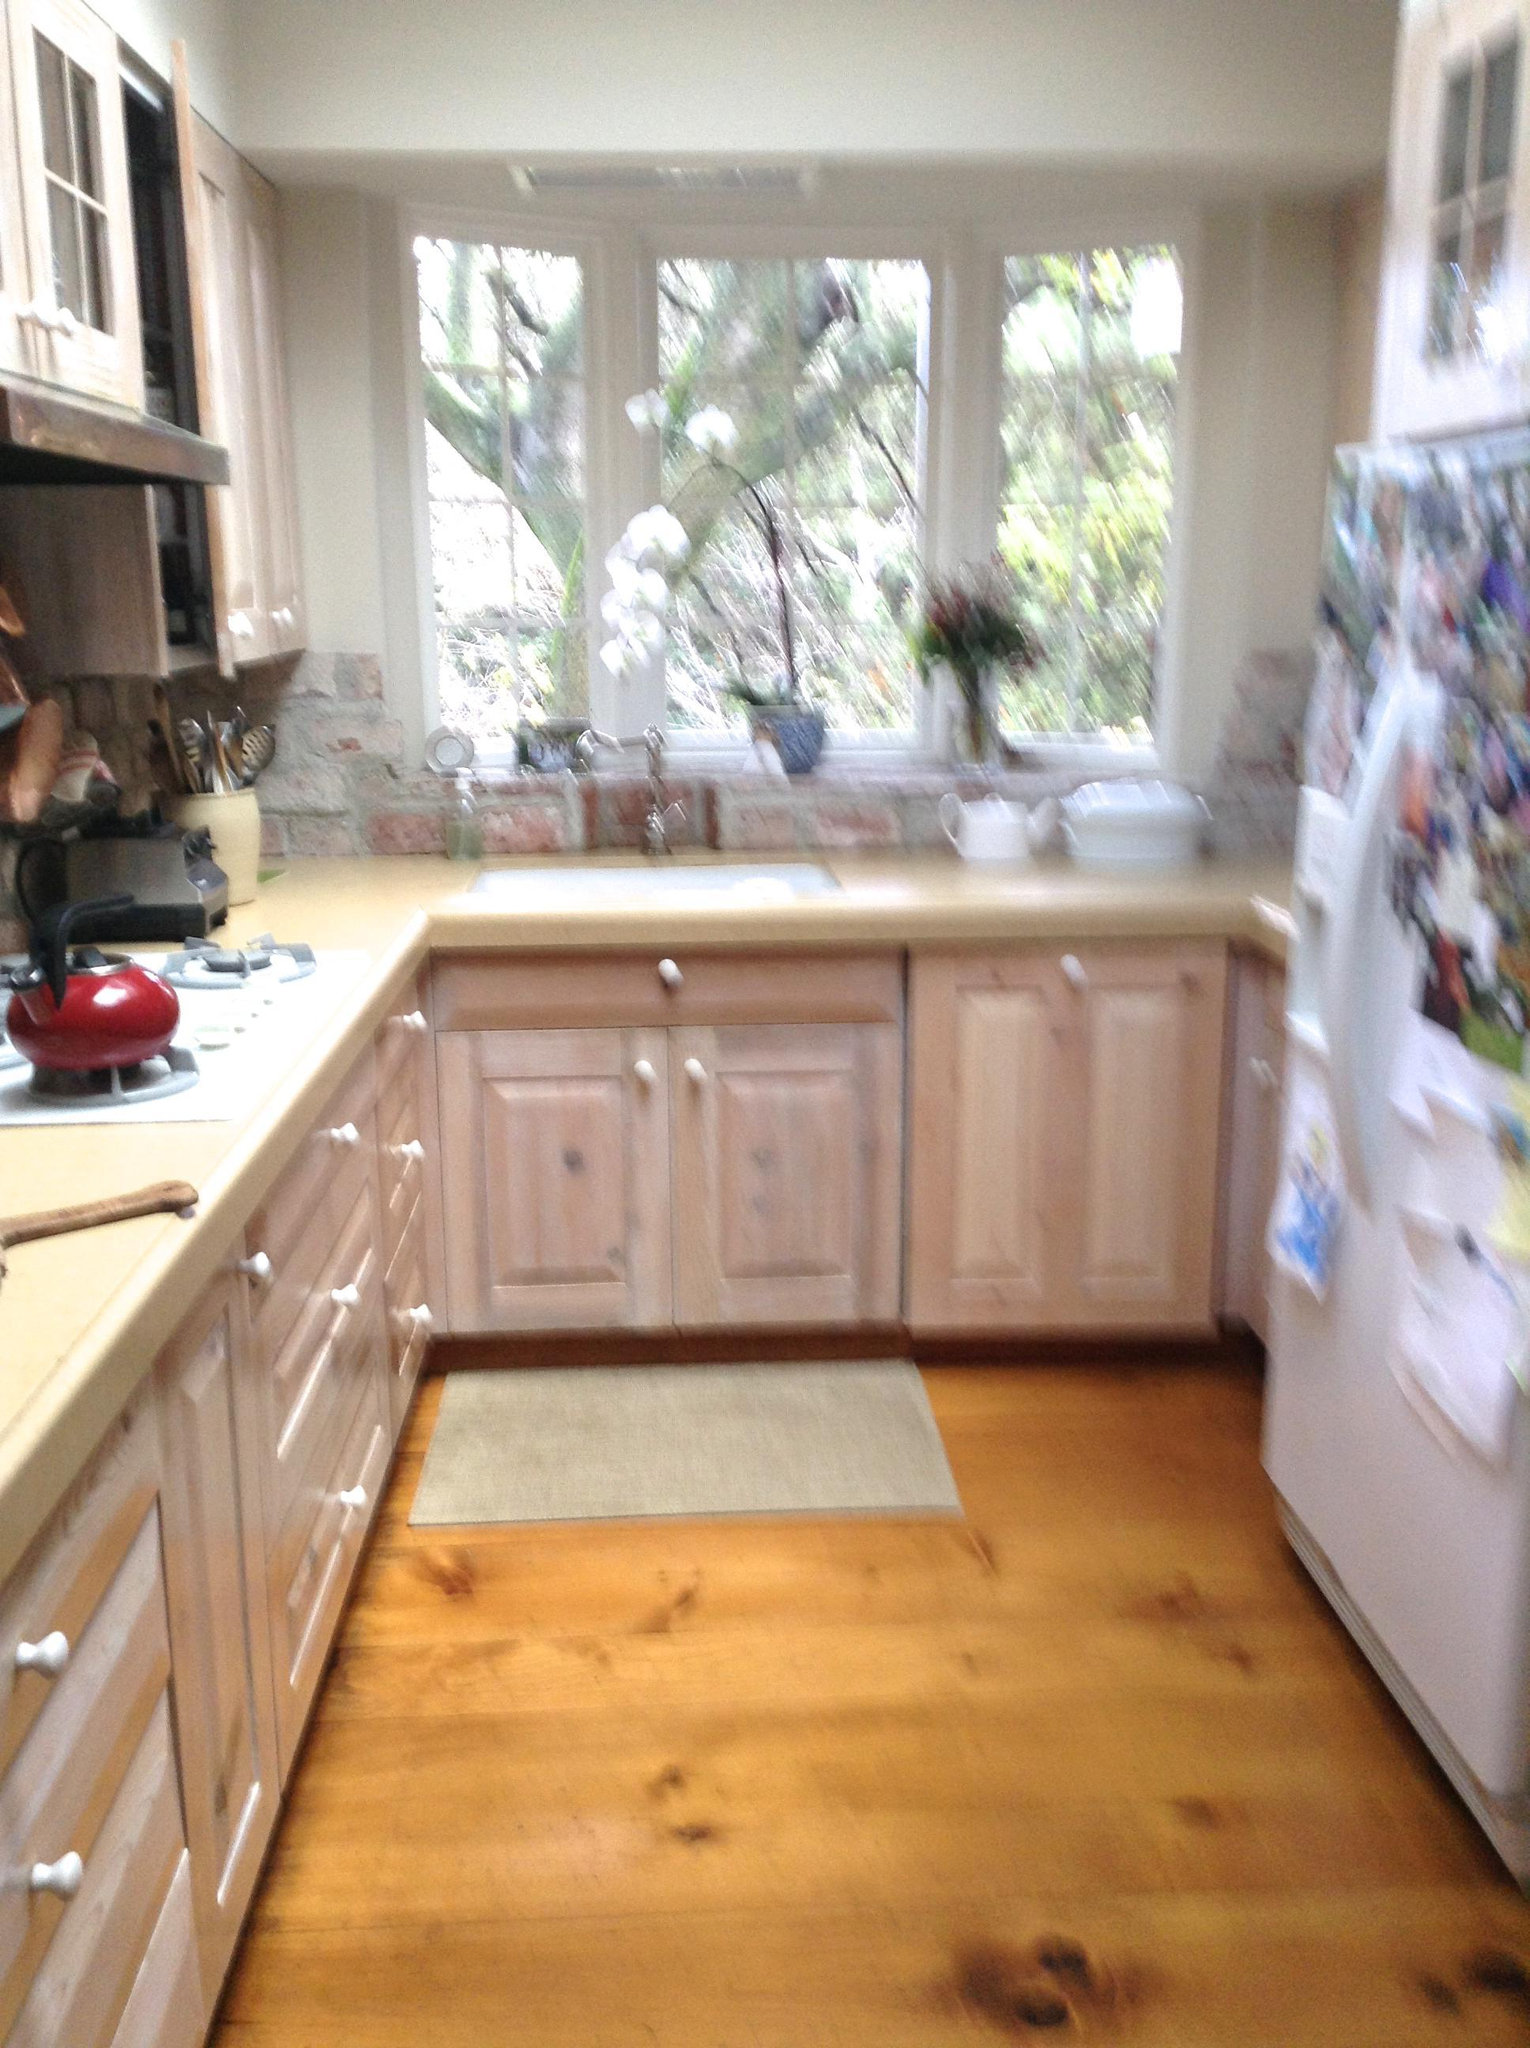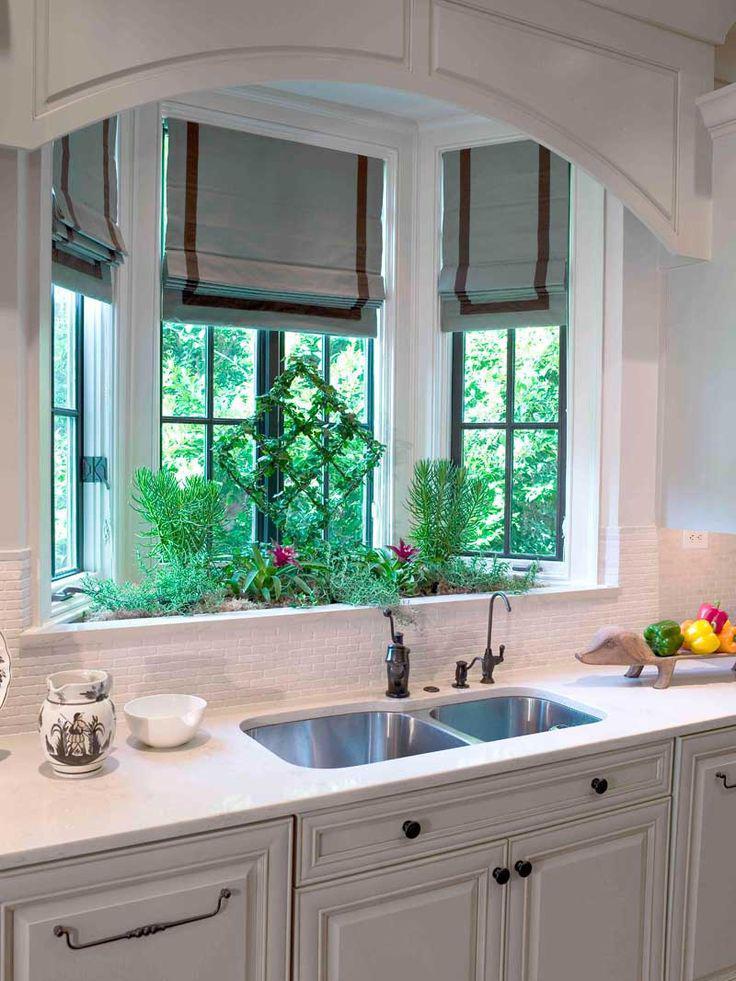The first image is the image on the left, the second image is the image on the right. Evaluate the accuracy of this statement regarding the images: "Right image shows a bay window over a double sink in a white kitchen.". Is it true? Answer yes or no. Yes. The first image is the image on the left, the second image is the image on the right. Analyze the images presented: Is the assertion "In one image, a double sink with goose neck faucet is in front of a white three-bay window that has equal size window panes." valid? Answer yes or no. Yes. 